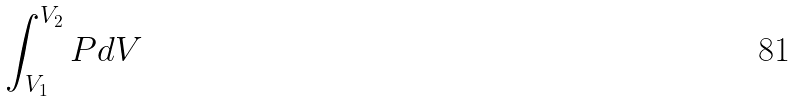<formula> <loc_0><loc_0><loc_500><loc_500>\int _ { V _ { 1 } } ^ { V _ { 2 } } P d V</formula> 